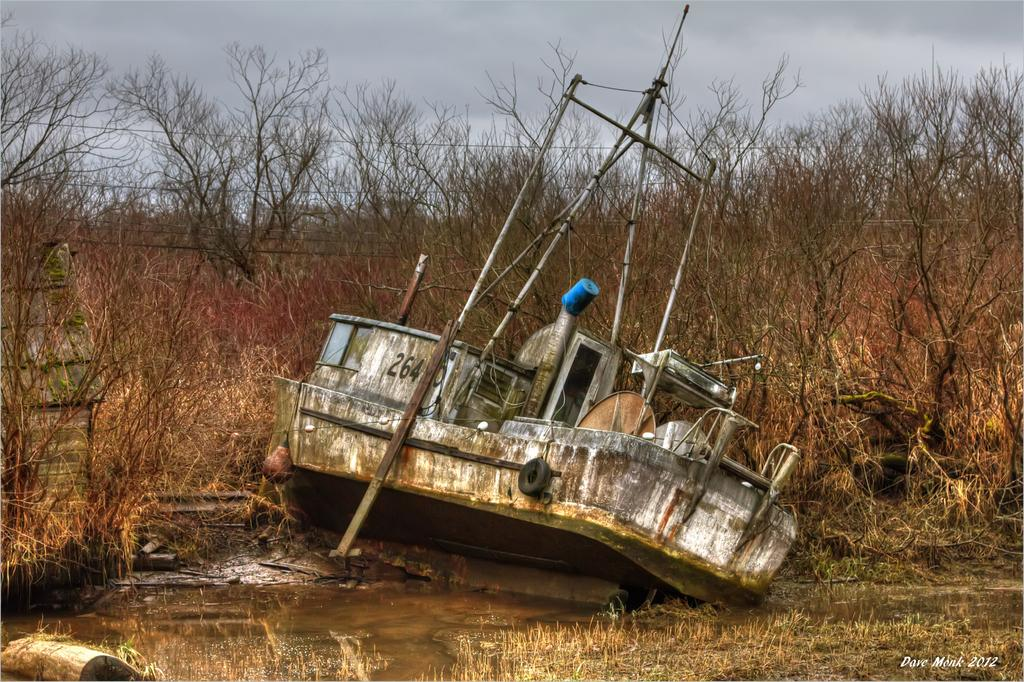What is the main subject of the image? The main subject of the image is a boat. What is the boat doing in the image? The boat is in the water, which suggests it is either floating or being used for transportation. What can be seen on the boat? The boat has poles and a number on it. What is visible in the background of the image? There are trees and the sky visible in the background of the image. Is there any text or marking in the image? Yes, there is a watermark in the right bottom corner of the image. What type of business is being conducted on the boat in the image? There is no indication of any business being conducted on the boat in the image. Can you see any chess pieces on the boat in the image? There are no chess pieces visible on the boat in the image. 